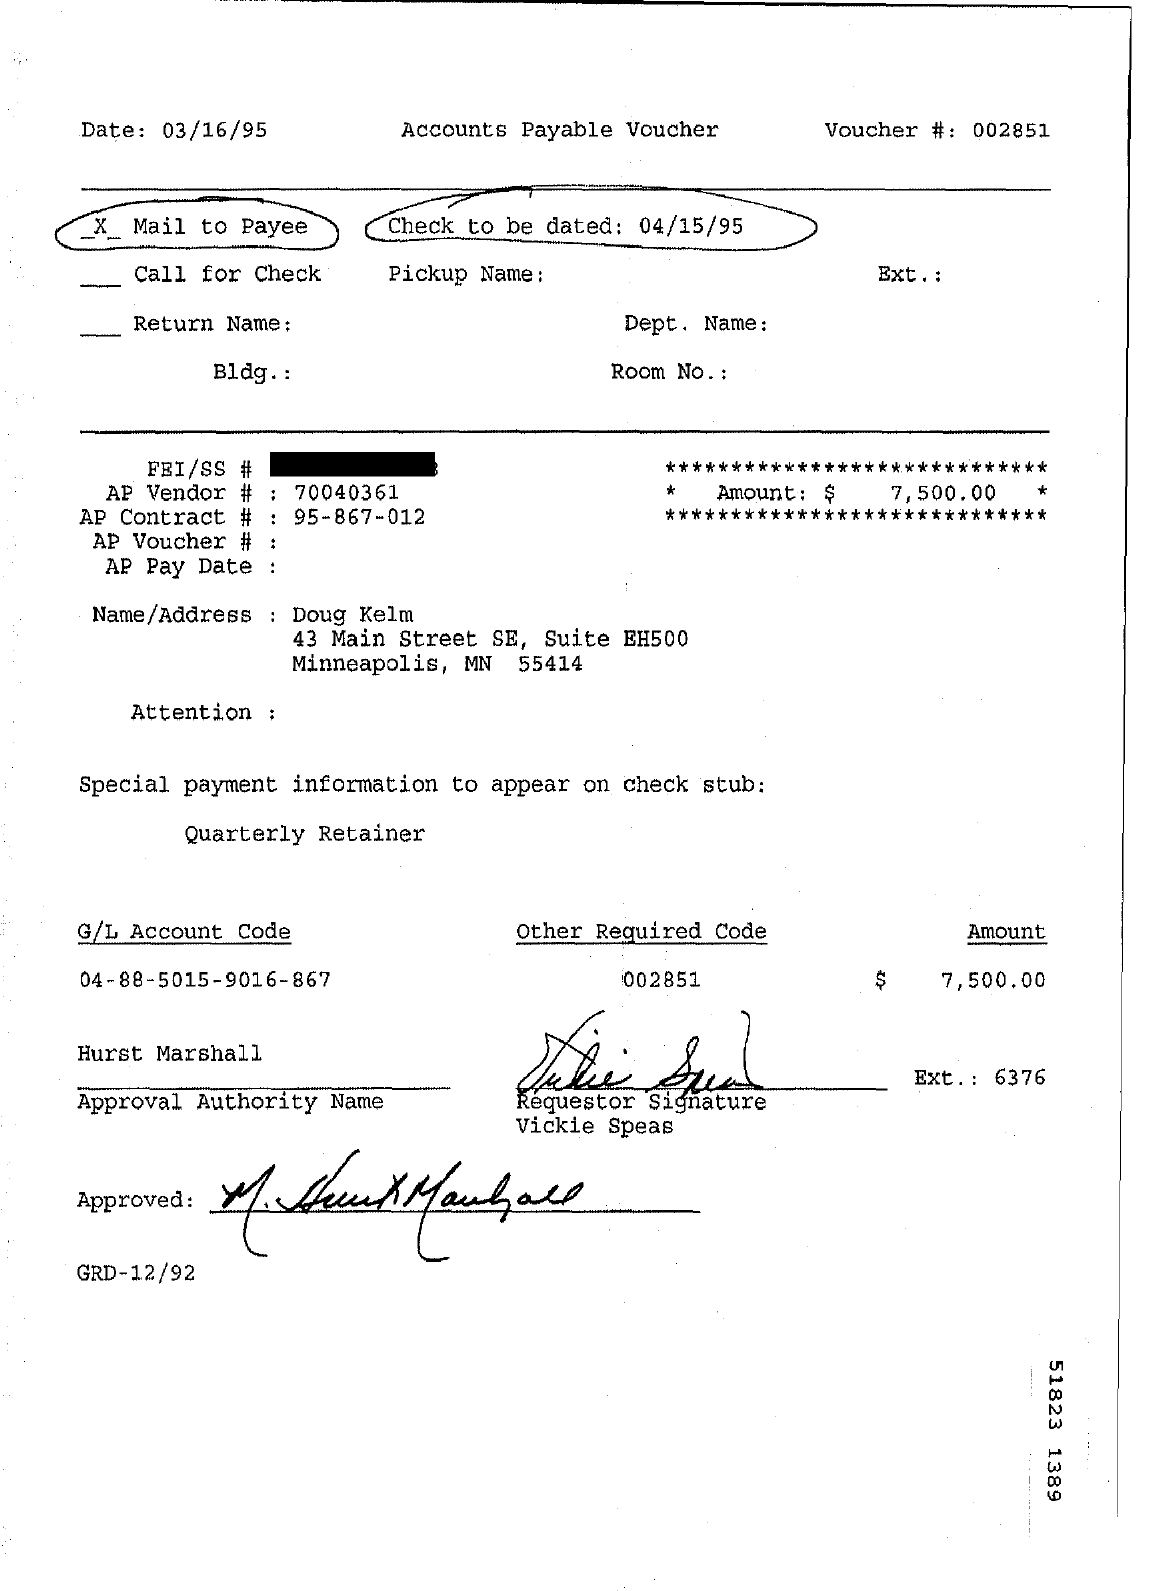Highlight a few significant elements in this photo. On what date is the check due? The AP contract number is 95-867-012. The GL Account Code mentioned is 04-88-5015-9016-867... What is the other required code?" is a question that requires a response. The AP vendor number is 70040361. 